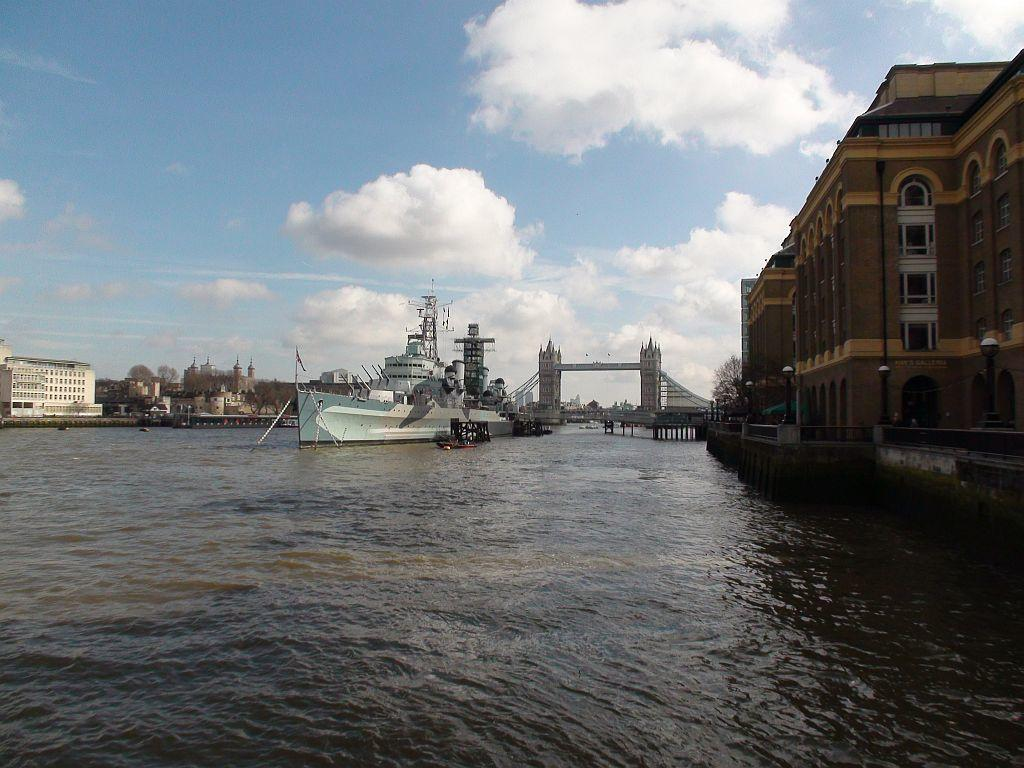What is the main subject of the image? There is a ship in the water. What can be seen in the background of the image? There are buildings and trees in the background of the image. How would you describe the sky in the image? The sky is blue and cloudy. What type of scarf is draped over the cub in the image? There is no scarf or cub present in the image; it features a ship in the water with a blue and cloudy sky in the background. 